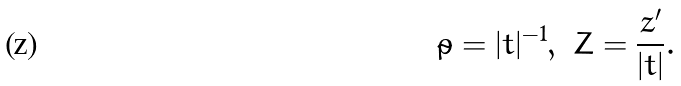<formula> <loc_0><loc_0><loc_500><loc_500>\tilde { \rho } = | t | ^ { - 1 } , \ Z = \frac { z ^ { \prime } } { | t | } .</formula> 